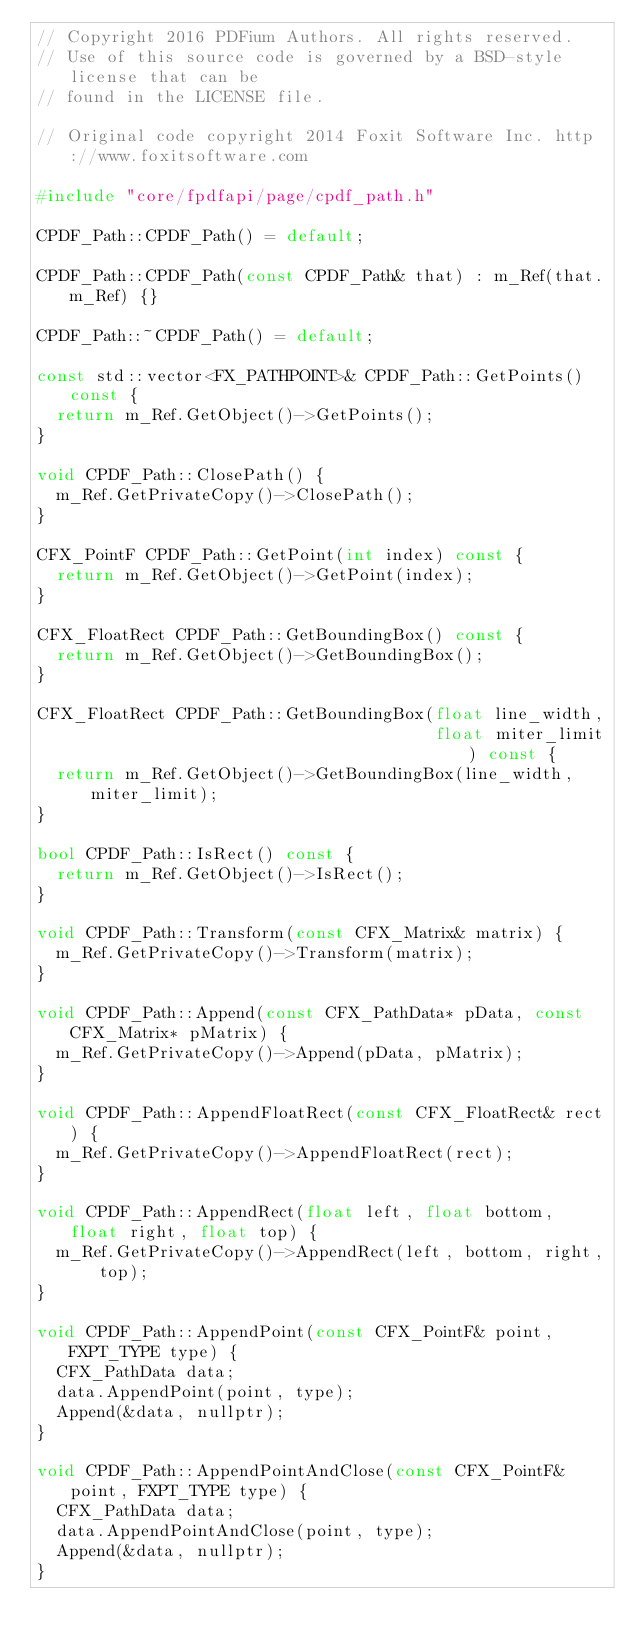<code> <loc_0><loc_0><loc_500><loc_500><_C++_>// Copyright 2016 PDFium Authors. All rights reserved.
// Use of this source code is governed by a BSD-style license that can be
// found in the LICENSE file.

// Original code copyright 2014 Foxit Software Inc. http://www.foxitsoftware.com

#include "core/fpdfapi/page/cpdf_path.h"

CPDF_Path::CPDF_Path() = default;

CPDF_Path::CPDF_Path(const CPDF_Path& that) : m_Ref(that.m_Ref) {}

CPDF_Path::~CPDF_Path() = default;

const std::vector<FX_PATHPOINT>& CPDF_Path::GetPoints() const {
  return m_Ref.GetObject()->GetPoints();
}

void CPDF_Path::ClosePath() {
  m_Ref.GetPrivateCopy()->ClosePath();
}

CFX_PointF CPDF_Path::GetPoint(int index) const {
  return m_Ref.GetObject()->GetPoint(index);
}

CFX_FloatRect CPDF_Path::GetBoundingBox() const {
  return m_Ref.GetObject()->GetBoundingBox();
}

CFX_FloatRect CPDF_Path::GetBoundingBox(float line_width,
                                        float miter_limit) const {
  return m_Ref.GetObject()->GetBoundingBox(line_width, miter_limit);
}

bool CPDF_Path::IsRect() const {
  return m_Ref.GetObject()->IsRect();
}

void CPDF_Path::Transform(const CFX_Matrix& matrix) {
  m_Ref.GetPrivateCopy()->Transform(matrix);
}

void CPDF_Path::Append(const CFX_PathData* pData, const CFX_Matrix* pMatrix) {
  m_Ref.GetPrivateCopy()->Append(pData, pMatrix);
}

void CPDF_Path::AppendFloatRect(const CFX_FloatRect& rect) {
  m_Ref.GetPrivateCopy()->AppendFloatRect(rect);
}

void CPDF_Path::AppendRect(float left, float bottom, float right, float top) {
  m_Ref.GetPrivateCopy()->AppendRect(left, bottom, right, top);
}

void CPDF_Path::AppendPoint(const CFX_PointF& point, FXPT_TYPE type) {
  CFX_PathData data;
  data.AppendPoint(point, type);
  Append(&data, nullptr);
}

void CPDF_Path::AppendPointAndClose(const CFX_PointF& point, FXPT_TYPE type) {
  CFX_PathData data;
  data.AppendPointAndClose(point, type);
  Append(&data, nullptr);
}
</code> 